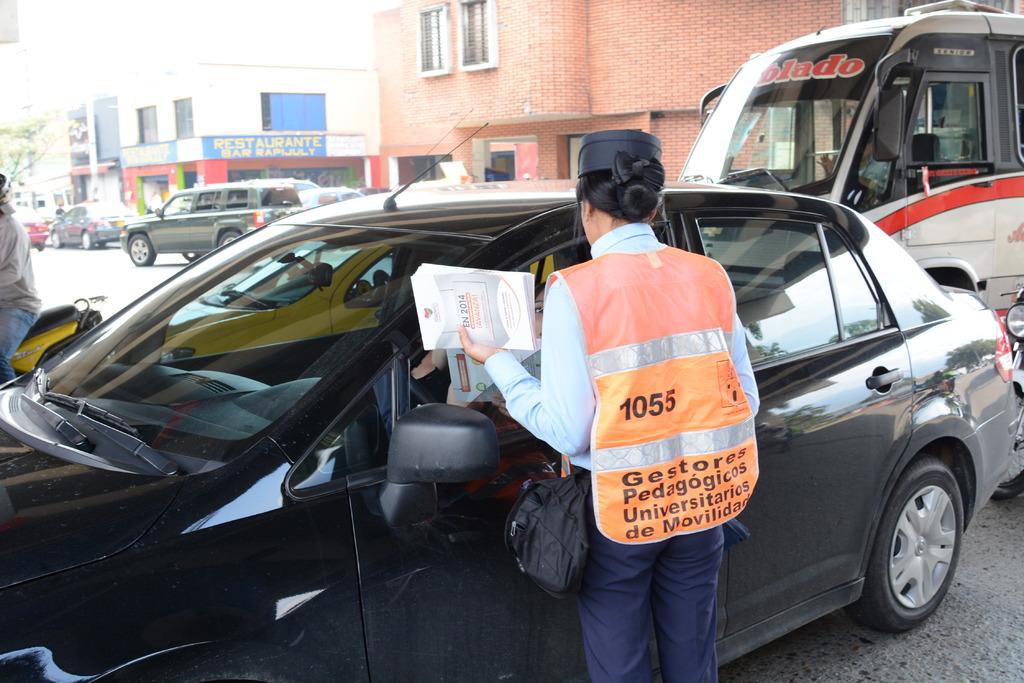What year is printed on the paper in the woman's hand?
Your answer should be compact. 2014. What is the number on this man's back?
Your answer should be very brief. 1055. 